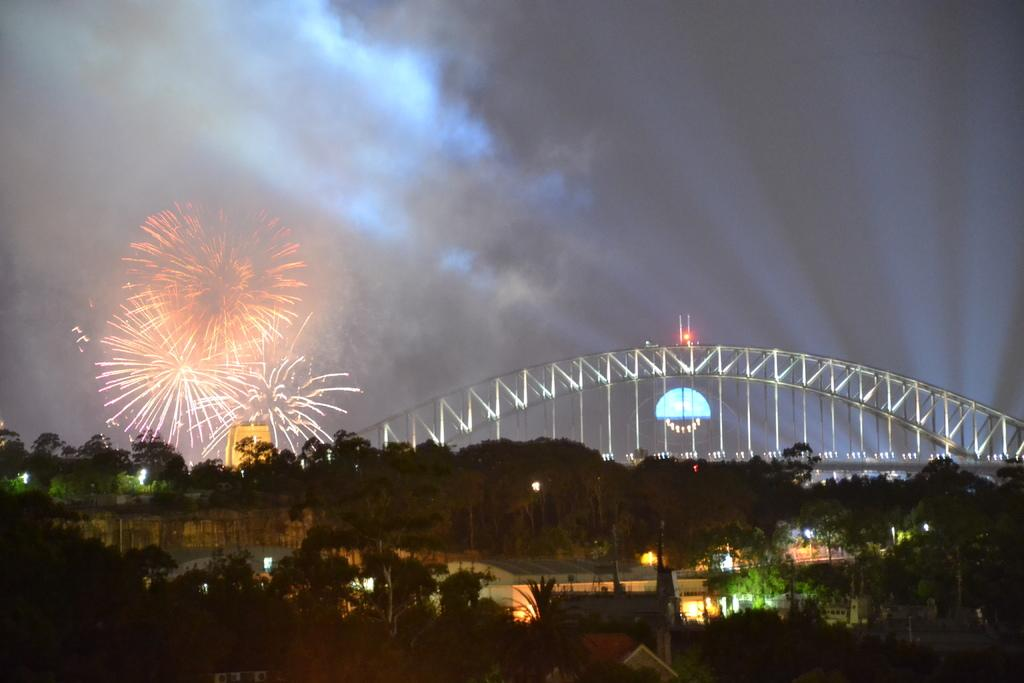What type of natural elements can be seen in the image? There are trees in the image. What artificial elements can be seen in the image? There are lights, a building, and a bridge in the image. What additional feature is present in the image? Light sparkles are visible in the image. What part of the natural environment is visible in the image? The sky is visible in the image. Can you tell me how many dinosaurs are crossing the bridge in the image? There are no dinosaurs present in the image; it features trees, lights, a building, a bridge, light sparkles, and the sky. What type of harbor can be seen near the bridge in the image? There is no harbor present in the image; it features trees, lights, a building, a bridge, light sparkles, and the sky. 